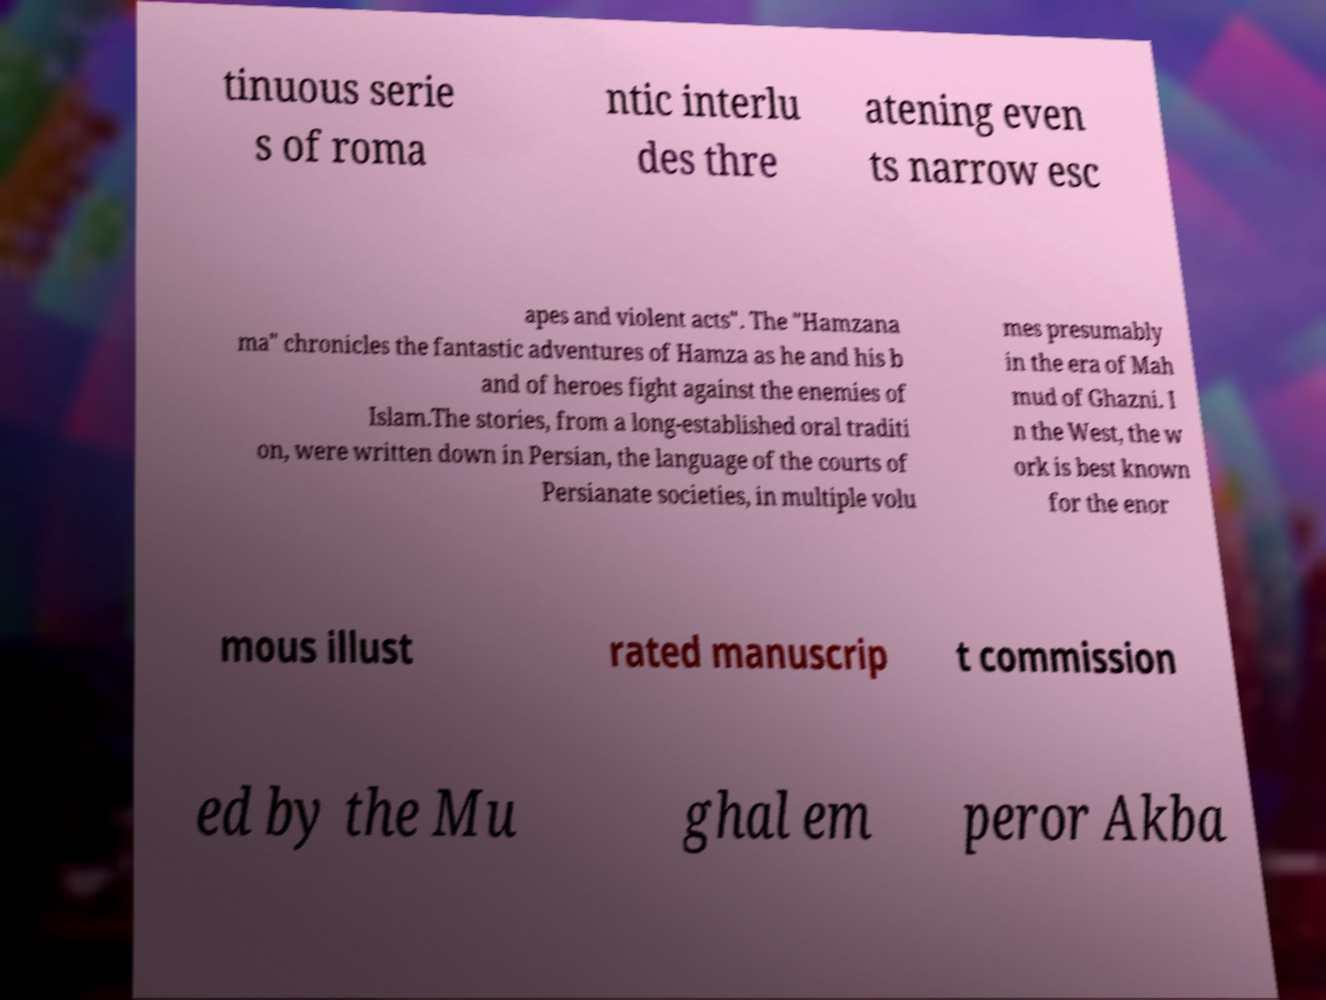I need the written content from this picture converted into text. Can you do that? tinuous serie s of roma ntic interlu des thre atening even ts narrow esc apes and violent acts". The "Hamzana ma" chronicles the fantastic adventures of Hamza as he and his b and of heroes fight against the enemies of Islam.The stories, from a long-established oral traditi on, were written down in Persian, the language of the courts of Persianate societies, in multiple volu mes presumably in the era of Mah mud of Ghazni. I n the West, the w ork is best known for the enor mous illust rated manuscrip t commission ed by the Mu ghal em peror Akba 